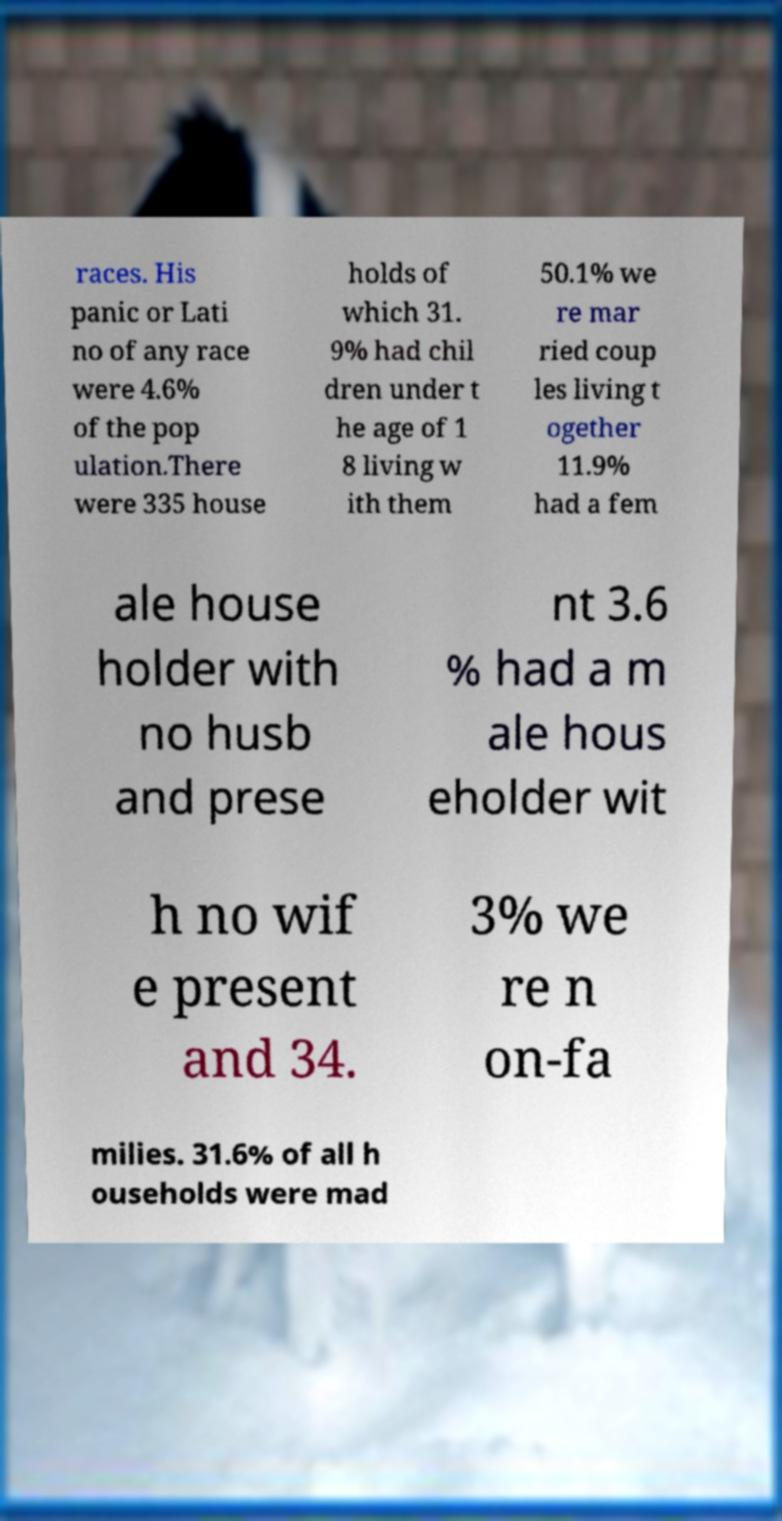Could you extract and type out the text from this image? races. His panic or Lati no of any race were 4.6% of the pop ulation.There were 335 house holds of which 31. 9% had chil dren under t he age of 1 8 living w ith them 50.1% we re mar ried coup les living t ogether 11.9% had a fem ale house holder with no husb and prese nt 3.6 % had a m ale hous eholder wit h no wif e present and 34. 3% we re n on-fa milies. 31.6% of all h ouseholds were mad 